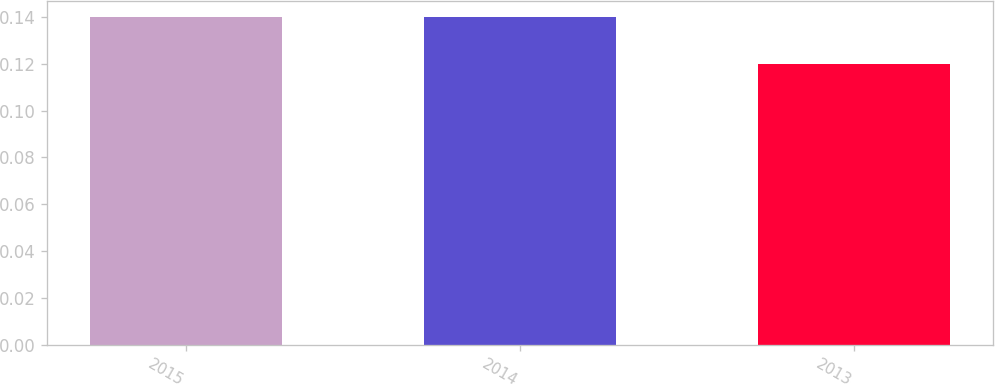Convert chart. <chart><loc_0><loc_0><loc_500><loc_500><bar_chart><fcel>2015<fcel>2014<fcel>2013<nl><fcel>0.14<fcel>0.14<fcel>0.12<nl></chart> 